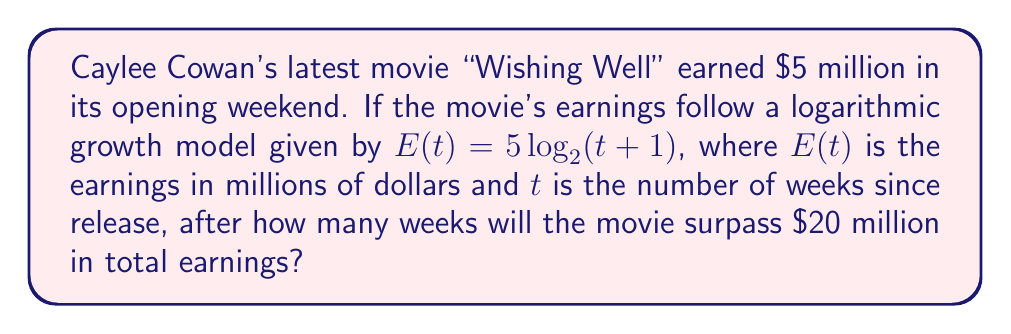Show me your answer to this math problem. Let's solve this step-by-step:

1) We need to find $t$ when $E(t) = 20$. So, we set up the equation:
   
   $20 = 5 \log_2(t+1)$

2) Divide both sides by 5:
   
   $4 = \log_2(t+1)$

3) To solve for $t$, we need to apply the inverse function (exponential) to both sides:
   
   $2^4 = t+1$

4) Simplify the left side:
   
   $16 = t+1$

5) Subtract 1 from both sides:
   
   $15 = t$

6) Therefore, the movie will surpass $20 million after 15 weeks.

7) To verify:
   $E(15) = 5 \log_2(15+1) = 5 \log_2(16) = 5 * 4 = 20$ million
Answer: 15 weeks 